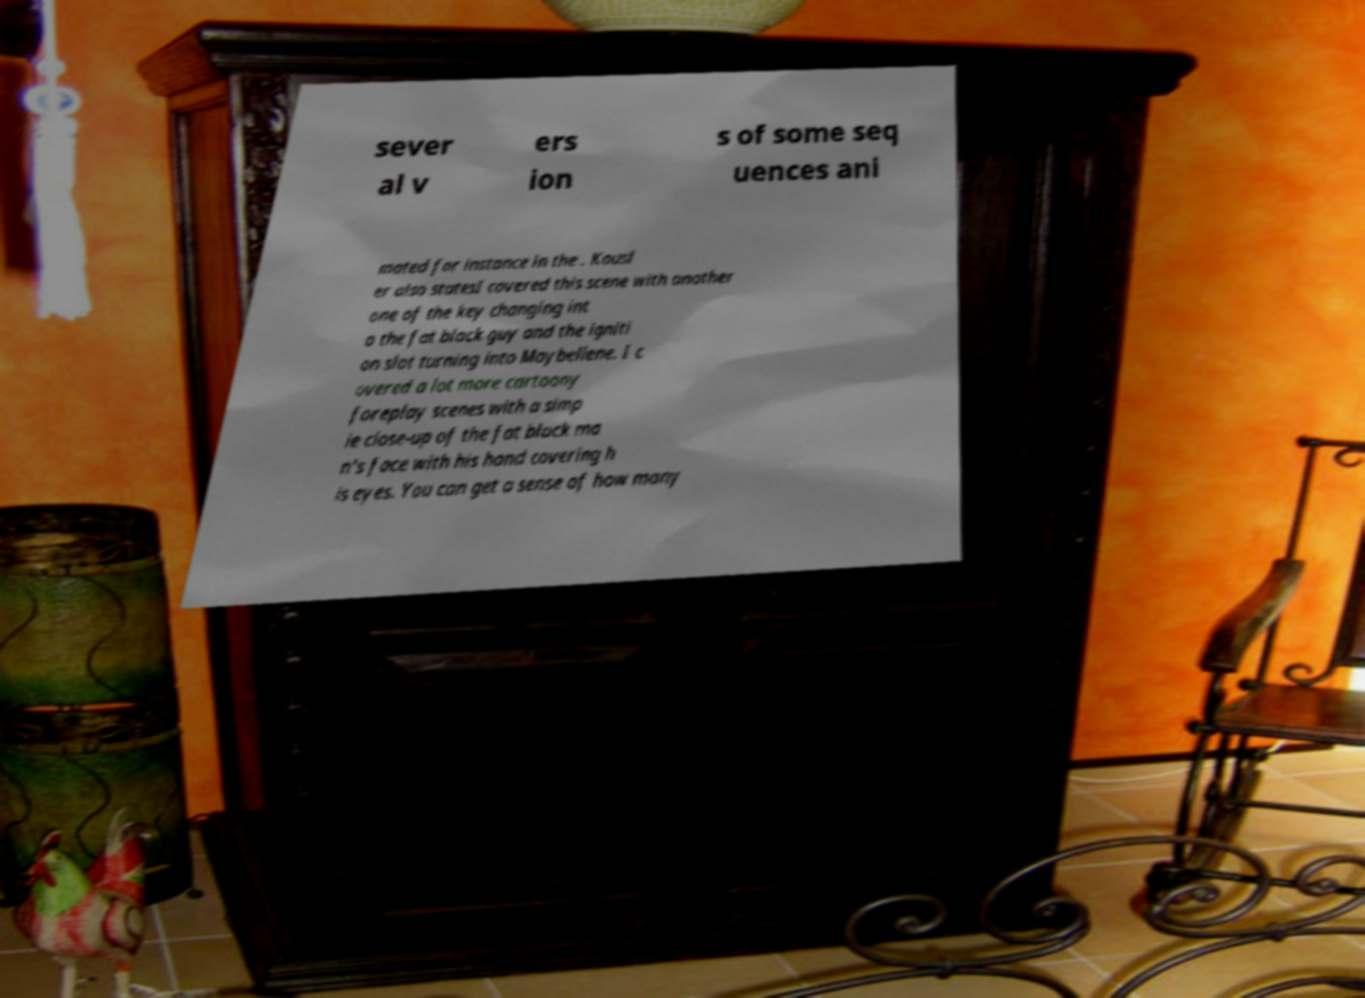For documentation purposes, I need the text within this image transcribed. Could you provide that? sever al v ers ion s of some seq uences ani mated for instance in the . Kausl er also statesI covered this scene with another one of the key changing int o the fat black guy and the igniti on slot turning into Maybellene. I c overed a lot more cartoony foreplay scenes with a simp le close-up of the fat black ma n's face with his hand covering h is eyes. You can get a sense of how many 